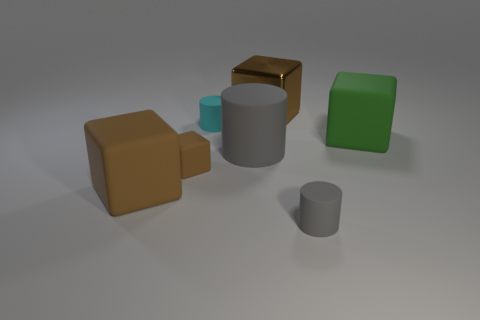How many brown cubes must be subtracted to get 1 brown cubes? 2 Subtract all big metallic blocks. How many blocks are left? 3 Subtract all red cylinders. How many brown cubes are left? 3 Add 3 small cylinders. How many objects exist? 10 Subtract 3 cylinders. How many cylinders are left? 0 Subtract all cyan cylinders. How many cylinders are left? 2 Subtract 0 yellow blocks. How many objects are left? 7 Subtract all cylinders. How many objects are left? 4 Subtract all purple blocks. Subtract all brown cylinders. How many blocks are left? 4 Subtract all metallic objects. Subtract all big brown metal things. How many objects are left? 5 